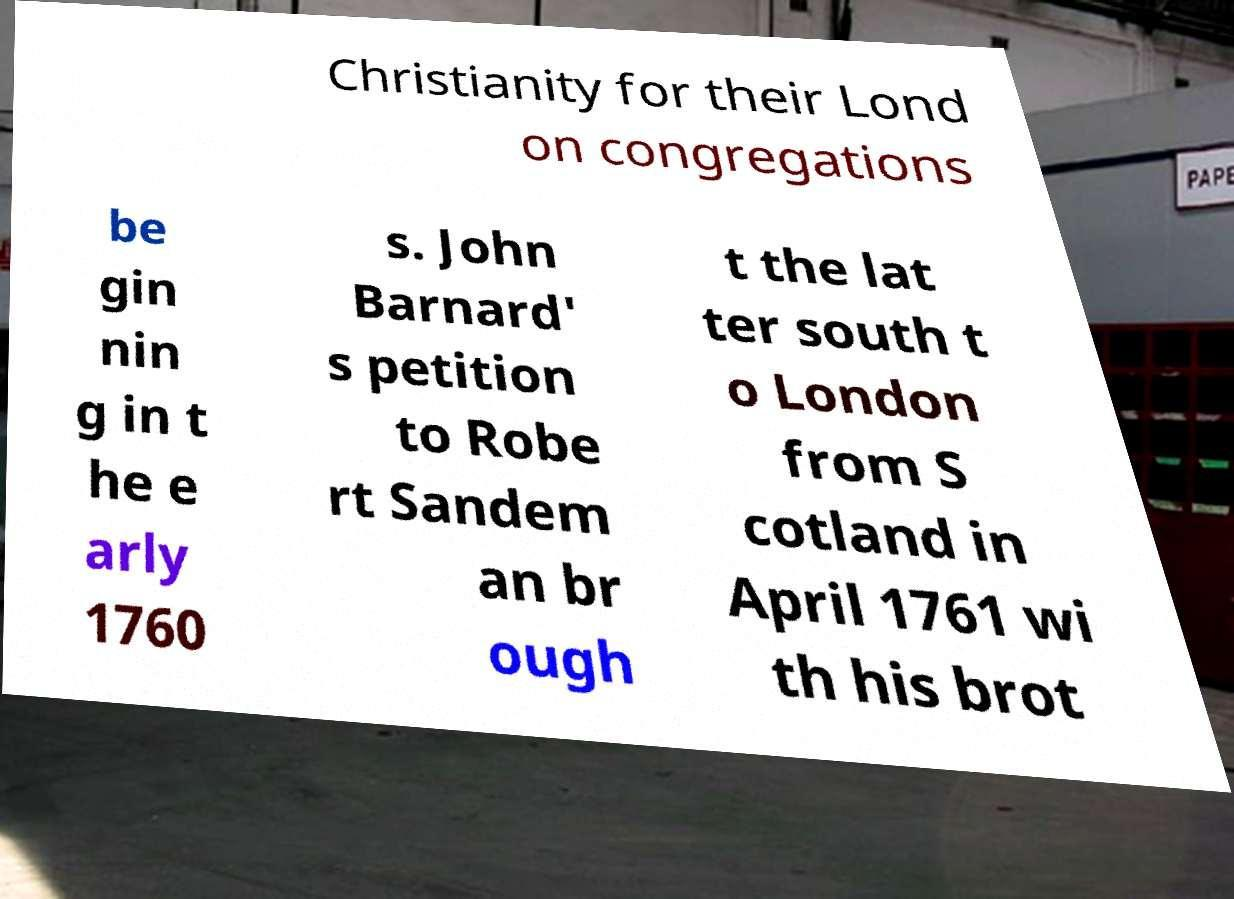What messages or text are displayed in this image? I need them in a readable, typed format. Christianity for their Lond on congregations be gin nin g in t he e arly 1760 s. John Barnard' s petition to Robe rt Sandem an br ough t the lat ter south t o London from S cotland in April 1761 wi th his brot 